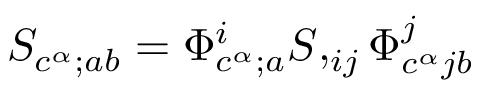Convert formula to latex. <formula><loc_0><loc_0><loc_500><loc_500>S _ { c ^ { \alpha } ; a b } = \Phi _ { c ^ { \alpha } ; a } ^ { i } S , _ { i j } \Phi _ { c ^ { \alpha } j b } ^ { j }</formula> 